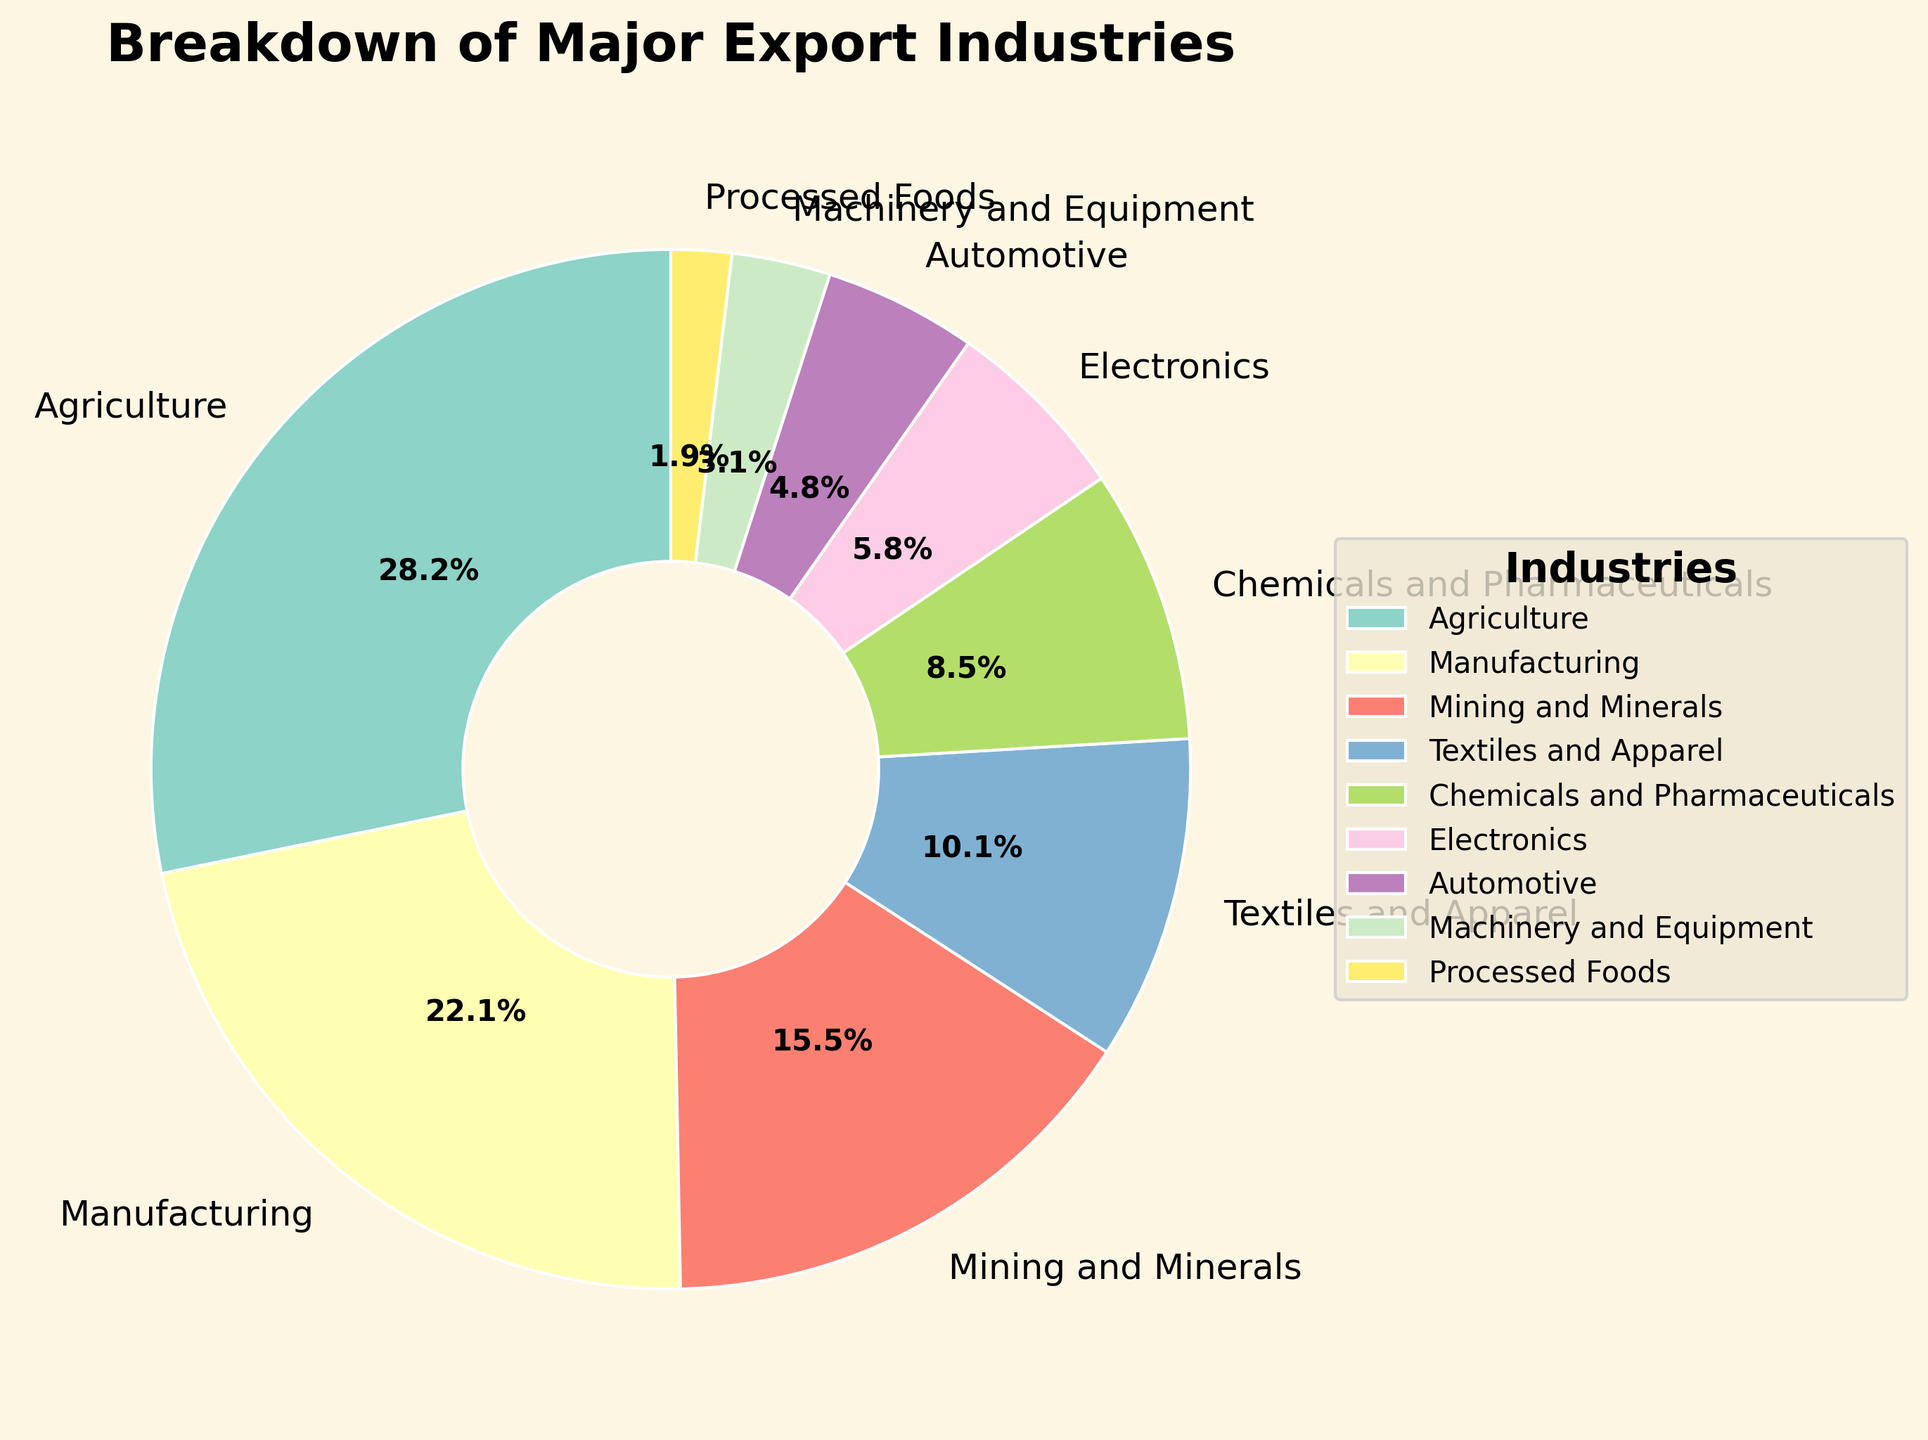What percentage of exports come from sectors other than Agriculture and Manufacturing? Agriculture and Manufacturing together account for 28.5% + 22.3% = 50.8%. Therefore, the rest is 100% - 50.8% = 49.2%.
Answer: 49.2% Which industry contributes more to exports: Chemicals and Pharmaceuticals or Automotive? Compare the percentages for Chemicals and Pharmaceuticals (8.6%) and Automotive (4.8%). Since 8.6% is greater than 4.8%, Chemicals and Pharmaceuticals contribute more.
Answer: Chemicals and Pharmaceuticals Is the contribution of Textiles and Apparel higher or lower than that of Mining and Minerals? Compare the percentages for Textiles and Apparel (10.2%) and Mining and Minerals (15.7%). Since 10.2% is less than 15.7%, Textiles and Apparel's contribution is lower.
Answer: Lower What's the combined percentage of exports from Chemicals and Pharmaceuticals, Electronics, and Automotive? Add the percentages for Chemicals and Pharmaceuticals (8.6%), Electronics (5.9%), and Automotive (4.8%): 8.6% + 5.9% + 4.8% = 19.3%.
Answer: 19.3% What is the difference in the percentage of exports between the highest and lowest contributing industries? The highest contributing industry is Agriculture with 28.5%, and the lowest is Processed Foods with 1.9%. The difference is 28.5% - 1.9% = 26.6%.
Answer: 26.6% Which industry has approximately half the percentage of Agriculture's contribution? Agriculture contributes 28.5%. The industry closest to half of 28.5% is Textiles and Apparel at 10.2%, which is close to half (14.25%).
Answer: Textiles and Apparel Arrange the industries in descending order of their export percentages. List the percentages from highest to lowest: 1. Agriculture (28.5%), 2. Manufacturing (22.3%), 3. Mining and Minerals (15.7%), 4. Textiles and Apparel (10.2%), 5. Chemicals and Pharmaceuticals (8.6%), 6. Electronics (5.9%), 7. Automotive (4.8%), 8. Machinery and Equipment (3.1%), 9. Processed Foods (1.9%).
Answer: Agriculture, Manufacturing, Mining and Minerals, Textiles and Apparel, Chemicals and Pharmaceuticals, Electronics, Automotive, Machinery and Equipment, Processed Foods If we combine the contributions of Manufacturing and Mining and Minerals, what percentage do they represent together? Add the percentages for Manufacturing (22.3%) and Mining and Minerals (15.7%): 22.3% + 15.7% = 38%.
Answer: 38% Does the Electronics industry contribute more or less than half of what the Manufacturing industry contributes? Half of Manufacturing's contribution is 22.3% / 2 = 11.15%. Electronics contribute 5.9%, which is less than 11.15%.
Answer: Less 